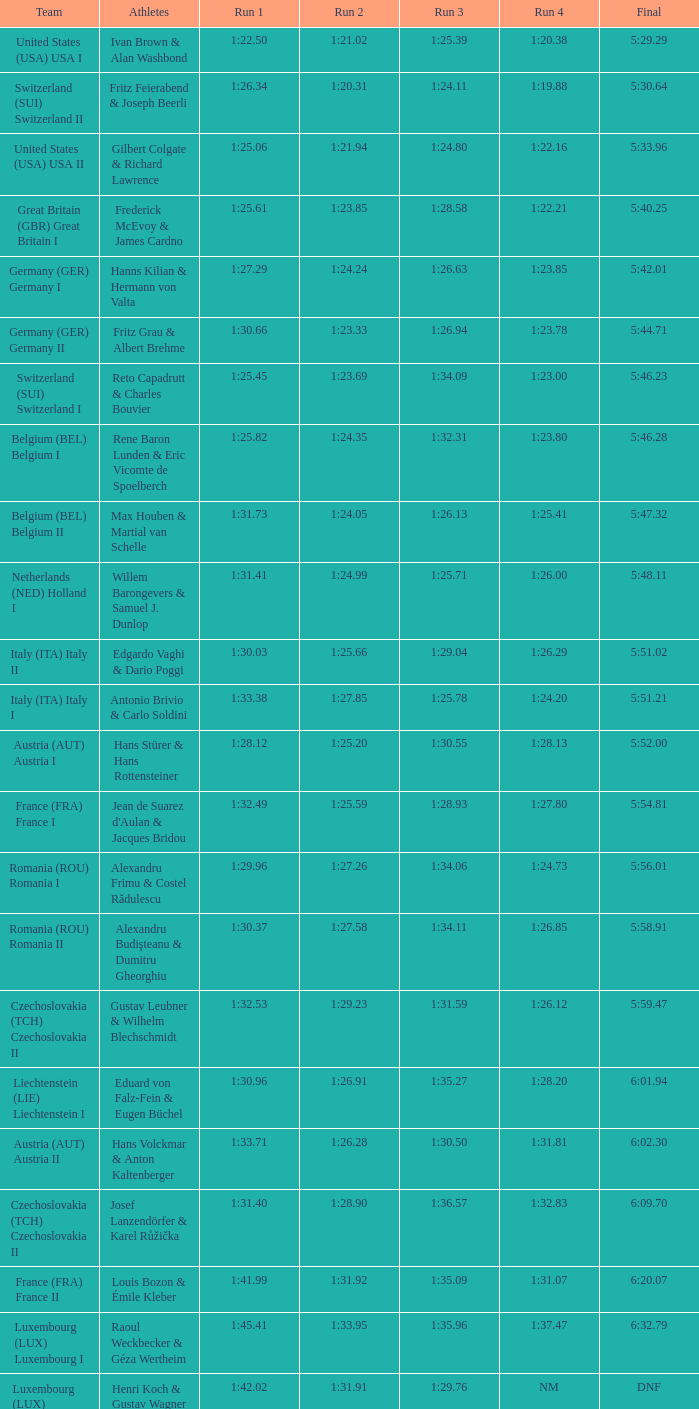03? 1:25.66. 